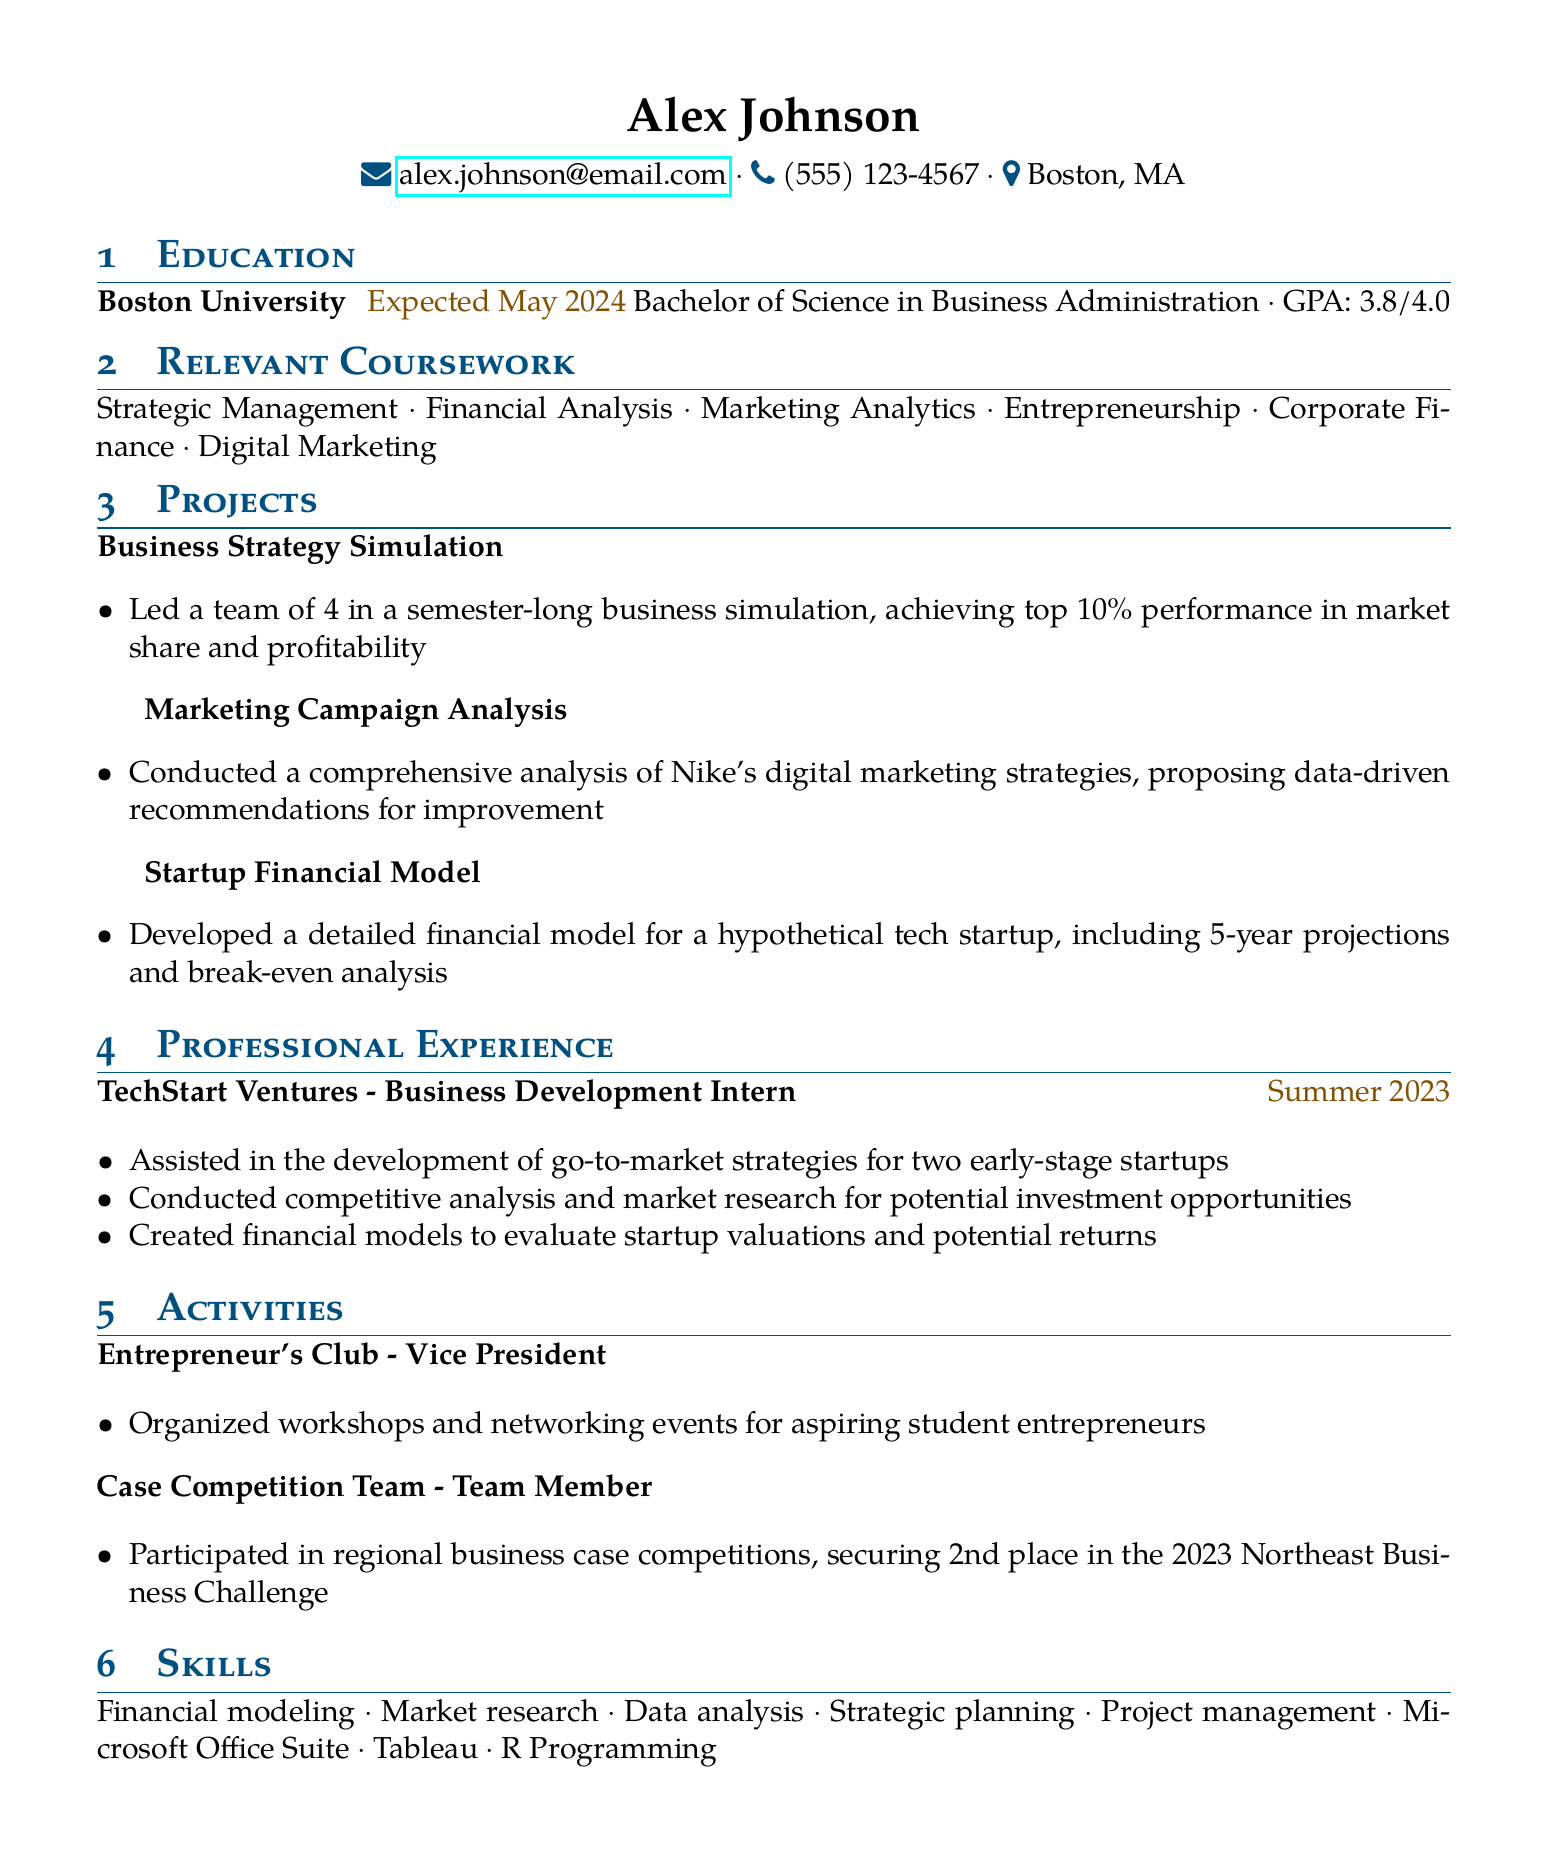What is Alex Johnson's GPA? The GPA is provided in the education section of the document as 3.8 out of 4.0.
Answer: 3.8/4.0 What degree is Alex Johnson pursuing? The document lists the degree being pursued as a Bachelor of Science in Business Administration.
Answer: Bachelor of Science in Business Administration What is the title of the first project listed? The first project in the projects section is titled "Business Strategy Simulation."
Answer: Business Strategy Simulation In which organization is Alex Johnson the Vice President? The activities section mentions the Entrepreneur's Club, where Alex serves as Vice President.
Answer: Entrepreneur's Club How long is the internship at TechStart Ventures? It specifies the duration of the internship as Summer 2023.
Answer: Summer 2023 What place did Alex achieve in the 2023 Northeast Business Challenge? The Case Competition Team secured 2nd place in this challenge, as stated in the activities section.
Answer: 2nd place What skills does Alex list related to data analysis? The skills section includes "Data analysis" as one of the listed skills.
Answer: Data analysis How many projects are included in the resume? The projects section lists a total of three projects undertaken by Alex.
Answer: Three 